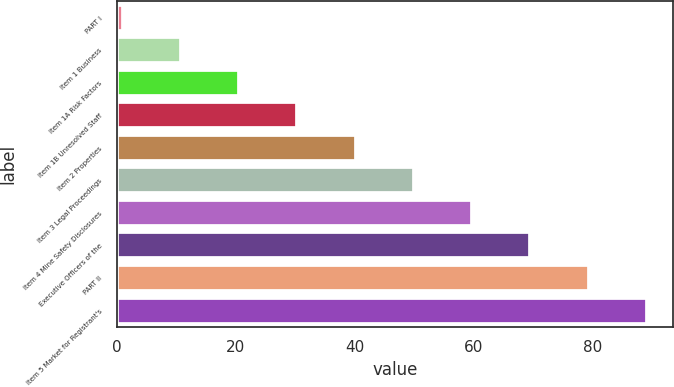<chart> <loc_0><loc_0><loc_500><loc_500><bar_chart><fcel>PART I<fcel>Item 1 Business<fcel>Item 1A Risk Factors<fcel>Item 1B Unresolved Staff<fcel>Item 2 Properties<fcel>Item 3 Legal Proceedings<fcel>Item 4 Mine Safety Disclosures<fcel>Executive Officers of the<fcel>PART II<fcel>Item 5 Market for Registrant's<nl><fcel>1<fcel>10.8<fcel>20.6<fcel>30.4<fcel>40.2<fcel>50<fcel>59.8<fcel>69.6<fcel>79.4<fcel>89.2<nl></chart> 